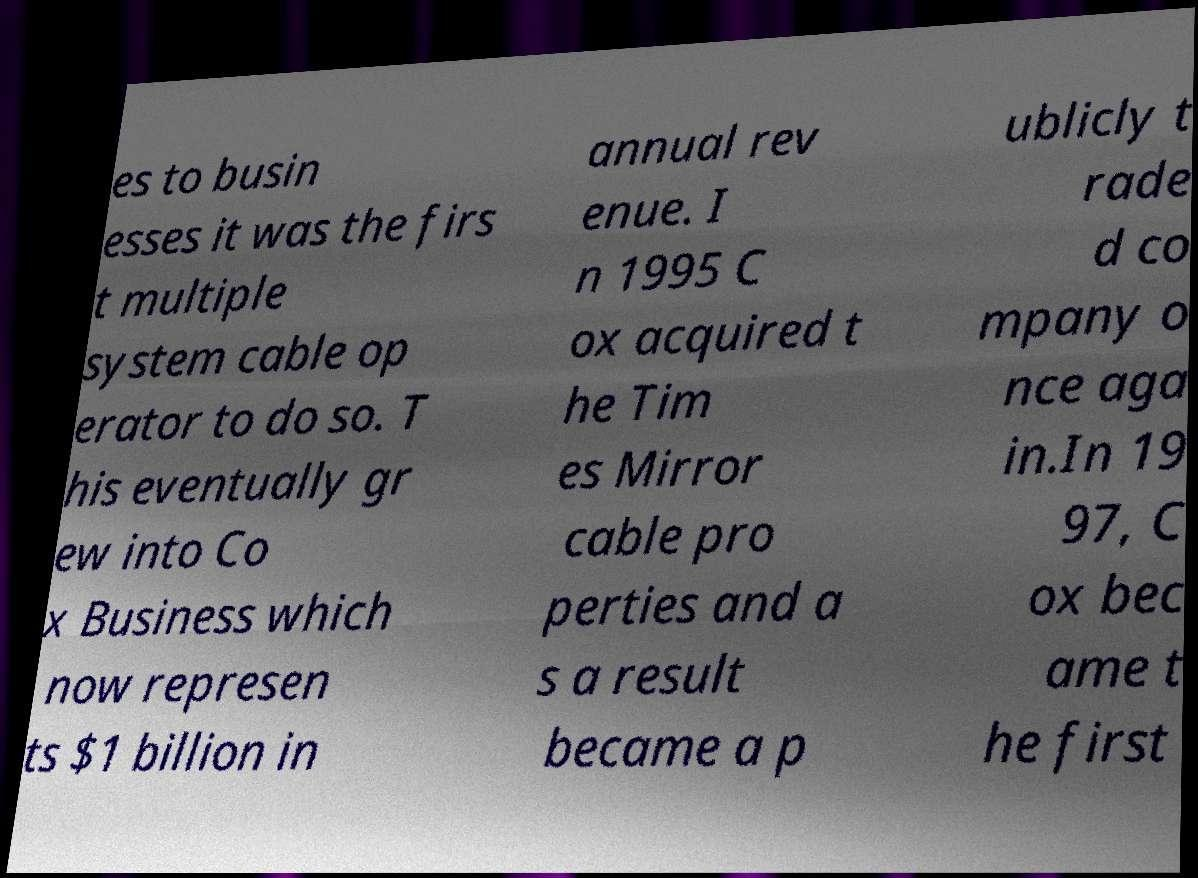Could you extract and type out the text from this image? es to busin esses it was the firs t multiple system cable op erator to do so. T his eventually gr ew into Co x Business which now represen ts $1 billion in annual rev enue. I n 1995 C ox acquired t he Tim es Mirror cable pro perties and a s a result became a p ublicly t rade d co mpany o nce aga in.In 19 97, C ox bec ame t he first 